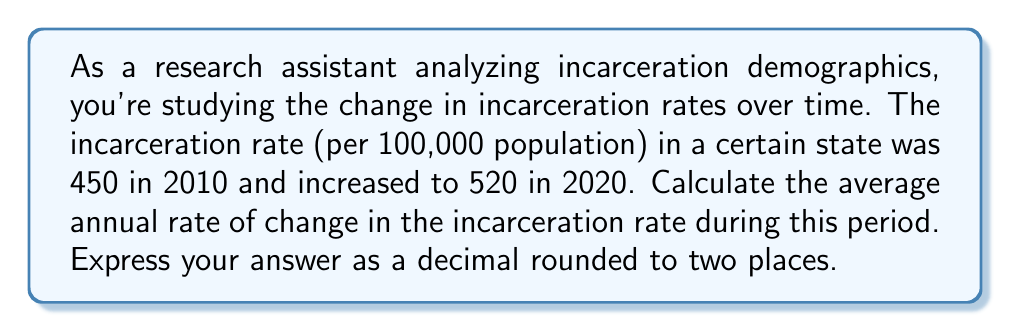Help me with this question. To solve this problem, we need to use the formula for the rate of change:

$$\text{Rate of Change} = \frac{\text{Change in Value}}{\text{Change in Time}}$$

Let's break it down step-by-step:

1. Identify the given information:
   - Initial incarceration rate (2010): 450 per 100,000
   - Final incarceration rate (2020): 520 per 100,000
   - Time period: 10 years

2. Calculate the change in incarceration rate:
   $$\text{Change in Rate} = \text{Final Rate} - \text{Initial Rate}$$
   $$\text{Change in Rate} = 520 - 450 = 70$$

3. Apply the rate of change formula:
   $$\text{Average Annual Rate of Change} = \frac{\text{Change in Rate}}{\text{Number of Years}}$$
   $$\text{Average Annual Rate of Change} = \frac{70}{10} = 7$$

4. Express the result as a decimal:
   The average annual rate of change is 7 per 100,000 population per year.

5. Round to two decimal places:
   7.00

Therefore, the average annual rate of change in the incarceration rate is 7.00 per 100,000 population per year.
Answer: 7.00 